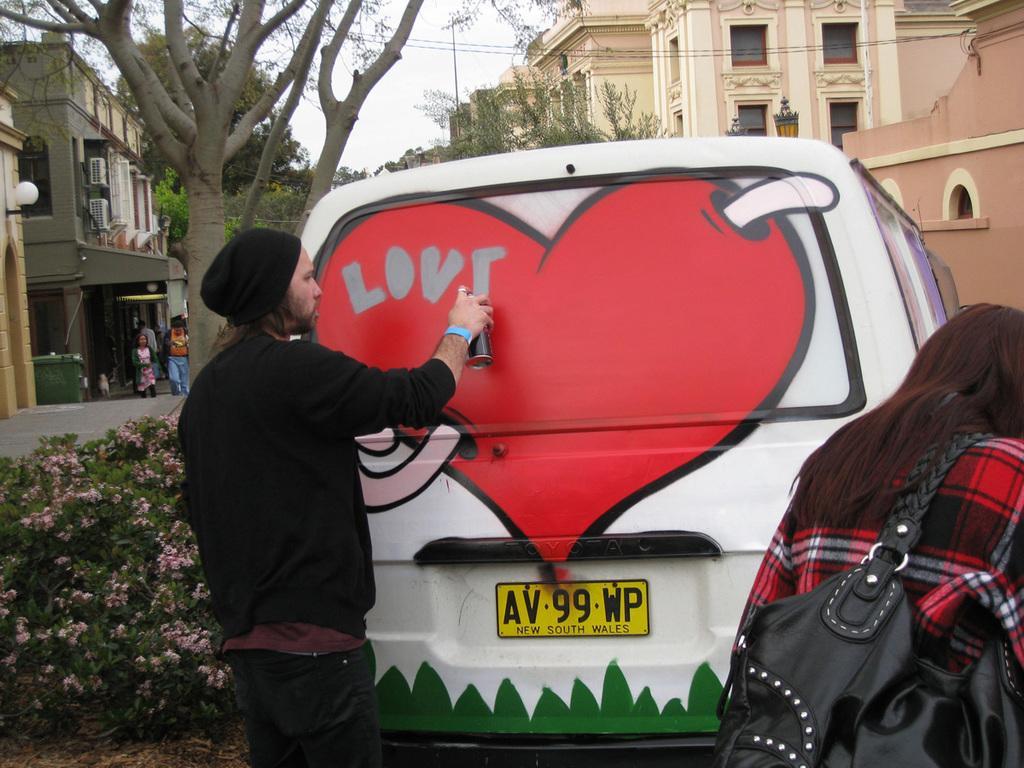Please provide a concise description of this image. In the center of the image there is a person wearing a black color jacket and a cap. He is doing graffiti on the car. There is a woman. In the background of the image there are buildings and trees. To the left side of the image there are plants. 